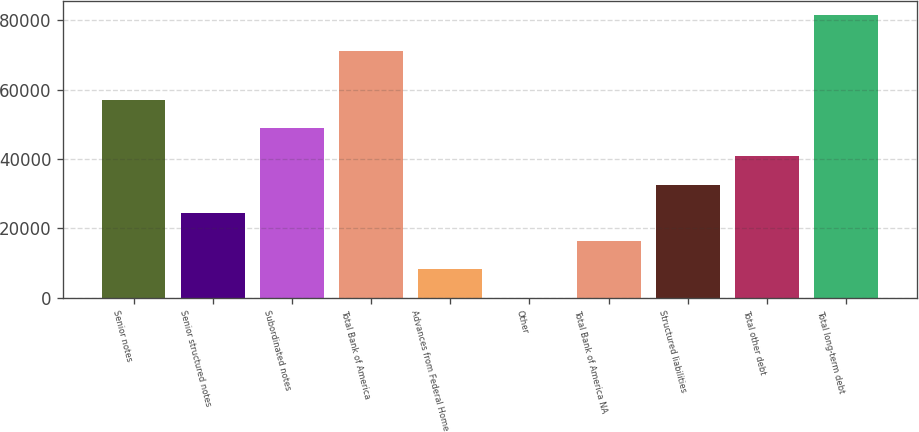Convert chart. <chart><loc_0><loc_0><loc_500><loc_500><bar_chart><fcel>Senior notes<fcel>Senior structured notes<fcel>Subordinated notes<fcel>Total Bank of America<fcel>Advances from Federal Home<fcel>Other<fcel>Total Bank of America NA<fcel>Structured liabilities<fcel>Total other debt<fcel>Total long-term debt<nl><fcel>57086.4<fcel>24481.6<fcel>48935.2<fcel>71182<fcel>8179.2<fcel>28<fcel>16330.4<fcel>32632.8<fcel>40784<fcel>81540<nl></chart> 